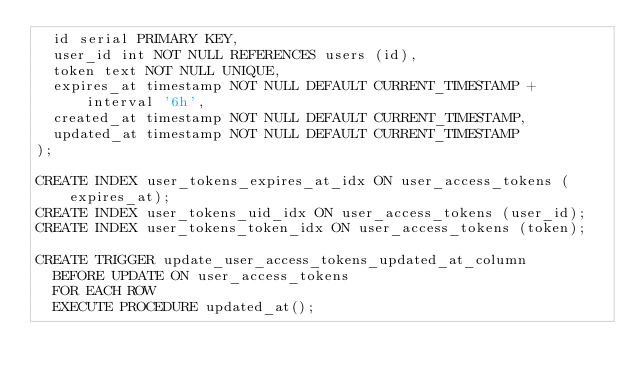Convert code to text. <code><loc_0><loc_0><loc_500><loc_500><_SQL_>  id serial PRIMARY KEY,
  user_id int NOT NULL REFERENCES users (id),
  token text NOT NULL UNIQUE,
  expires_at timestamp NOT NULL DEFAULT CURRENT_TIMESTAMP + interval '6h',
  created_at timestamp NOT NULL DEFAULT CURRENT_TIMESTAMP,
  updated_at timestamp NOT NULL DEFAULT CURRENT_TIMESTAMP
);

CREATE INDEX user_tokens_expires_at_idx ON user_access_tokens (expires_at);
CREATE INDEX user_tokens_uid_idx ON user_access_tokens (user_id);
CREATE INDEX user_tokens_token_idx ON user_access_tokens (token);

CREATE TRIGGER update_user_access_tokens_updated_at_column
  BEFORE UPDATE ON user_access_tokens
  FOR EACH ROW
  EXECUTE PROCEDURE updated_at();

</code> 